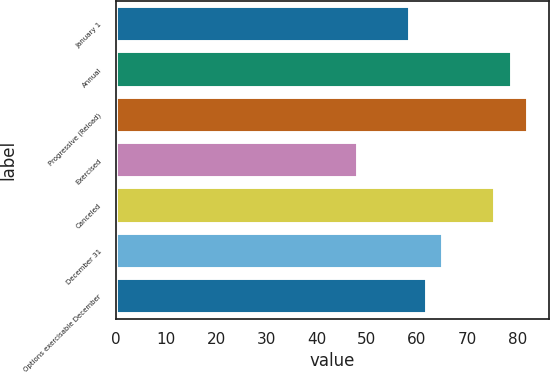Convert chart. <chart><loc_0><loc_0><loc_500><loc_500><bar_chart><fcel>January 1<fcel>Annual<fcel>Progressive (Reload)<fcel>Exercised<fcel>Canceled<fcel>December 31<fcel>Options exercisable December<nl><fcel>58.7<fcel>78.94<fcel>82.23<fcel>48.3<fcel>75.65<fcel>65.28<fcel>61.99<nl></chart> 